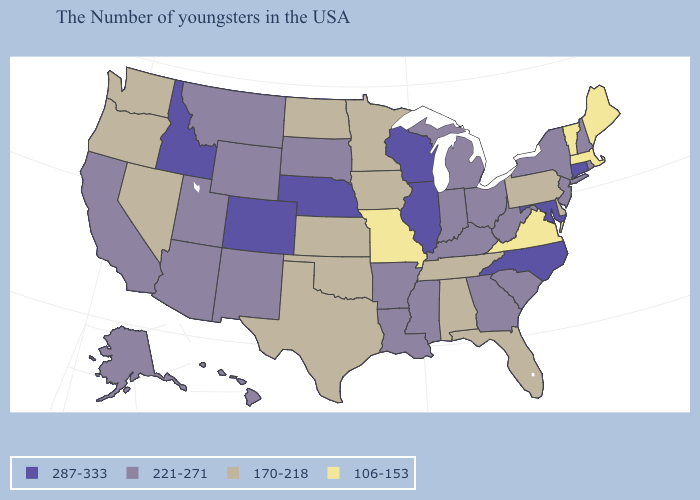Name the states that have a value in the range 106-153?
Keep it brief. Maine, Massachusetts, Vermont, Virginia, Missouri. Does Alaska have the same value as Idaho?
Be succinct. No. What is the value of Rhode Island?
Quick response, please. 221-271. How many symbols are there in the legend?
Keep it brief. 4. Which states have the lowest value in the MidWest?
Concise answer only. Missouri. What is the highest value in the West ?
Be succinct. 287-333. Does Washington have a higher value than Virginia?
Give a very brief answer. Yes. Name the states that have a value in the range 106-153?
Write a very short answer. Maine, Massachusetts, Vermont, Virginia, Missouri. Name the states that have a value in the range 287-333?
Short answer required. Connecticut, Maryland, North Carolina, Wisconsin, Illinois, Nebraska, Colorado, Idaho. How many symbols are there in the legend?
Give a very brief answer. 4. What is the highest value in the Northeast ?
Concise answer only. 287-333. Among the states that border Oklahoma , which have the highest value?
Be succinct. Colorado. What is the lowest value in the MidWest?
Write a very short answer. 106-153. What is the highest value in the USA?
Short answer required. 287-333. Does the first symbol in the legend represent the smallest category?
Write a very short answer. No. 